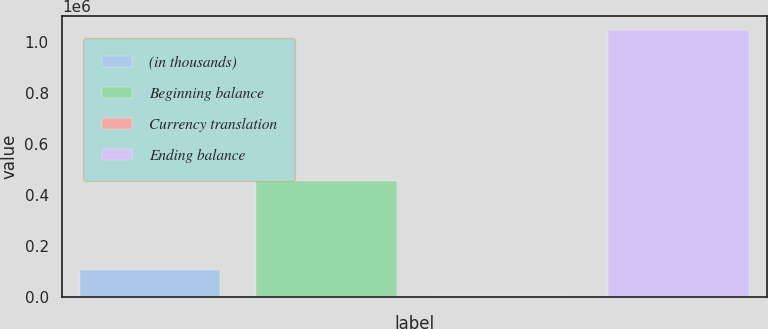Convert chart to OTSL. <chart><loc_0><loc_0><loc_500><loc_500><bar_chart><fcel>(in thousands)<fcel>Beginning balance<fcel>Currency translation<fcel>Ending balance<nl><fcel>106487<fcel>453689<fcel>1874<fcel>1.048e+06<nl></chart> 